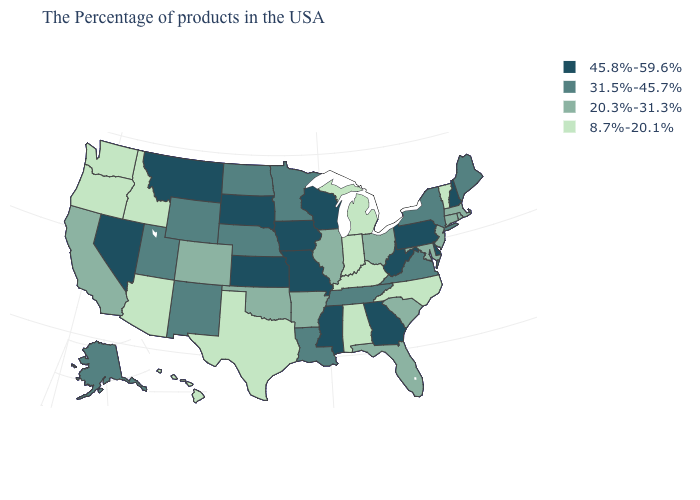What is the value of Washington?
Quick response, please. 8.7%-20.1%. Does Massachusetts have a lower value than Nevada?
Quick response, please. Yes. Name the states that have a value in the range 8.7%-20.1%?
Be succinct. Vermont, North Carolina, Michigan, Kentucky, Indiana, Alabama, Texas, Arizona, Idaho, Washington, Oregon, Hawaii. Does Indiana have the lowest value in the MidWest?
Answer briefly. Yes. What is the value of Pennsylvania?
Keep it brief. 45.8%-59.6%. Which states have the lowest value in the West?
Write a very short answer. Arizona, Idaho, Washington, Oregon, Hawaii. What is the value of Alabama?
Quick response, please. 8.7%-20.1%. Does Texas have the same value as North Dakota?
Concise answer only. No. Name the states that have a value in the range 45.8%-59.6%?
Write a very short answer. New Hampshire, Delaware, Pennsylvania, West Virginia, Georgia, Wisconsin, Mississippi, Missouri, Iowa, Kansas, South Dakota, Montana, Nevada. Does Vermont have the lowest value in the Northeast?
Quick response, please. Yes. What is the lowest value in the MidWest?
Give a very brief answer. 8.7%-20.1%. Among the states that border Mississippi , does Tennessee have the highest value?
Quick response, please. Yes. Among the states that border Nebraska , which have the highest value?
Concise answer only. Missouri, Iowa, Kansas, South Dakota. What is the value of Missouri?
Give a very brief answer. 45.8%-59.6%. Does Maryland have the lowest value in the South?
Answer briefly. No. 